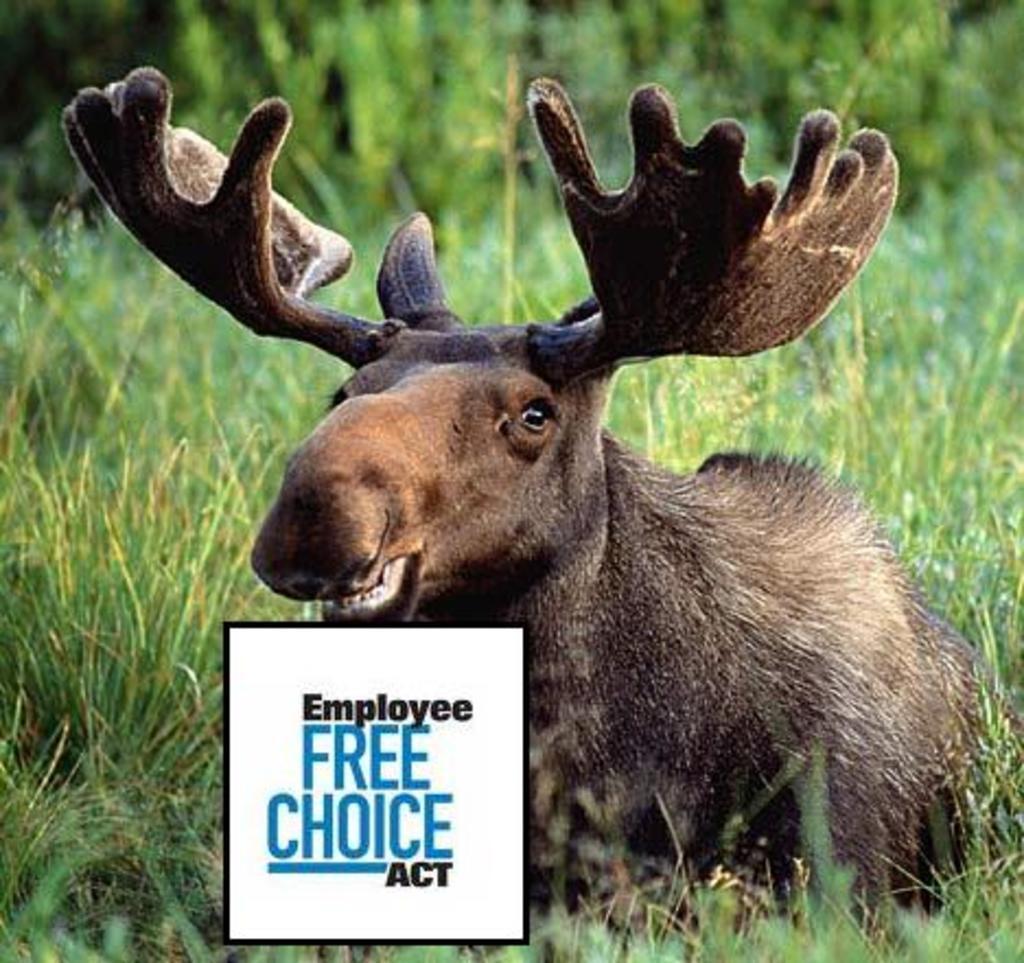How would you summarize this image in a sentence or two? In this image we can see an animal on the ground, there are some trees, grass and the text. 